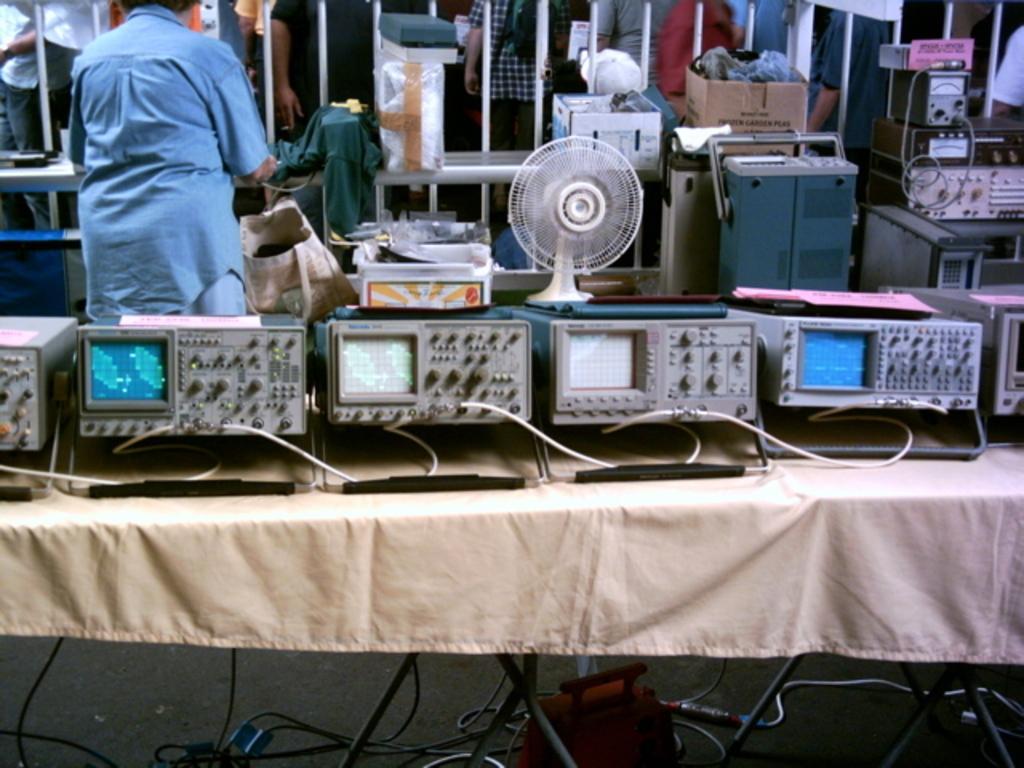Describe this image in one or two sentences. Here in this picture, in the front we can see some electronic devices present on a table and behind that we can see table fan and other electronic devices present over the place and on the left side we can see a person standing. 